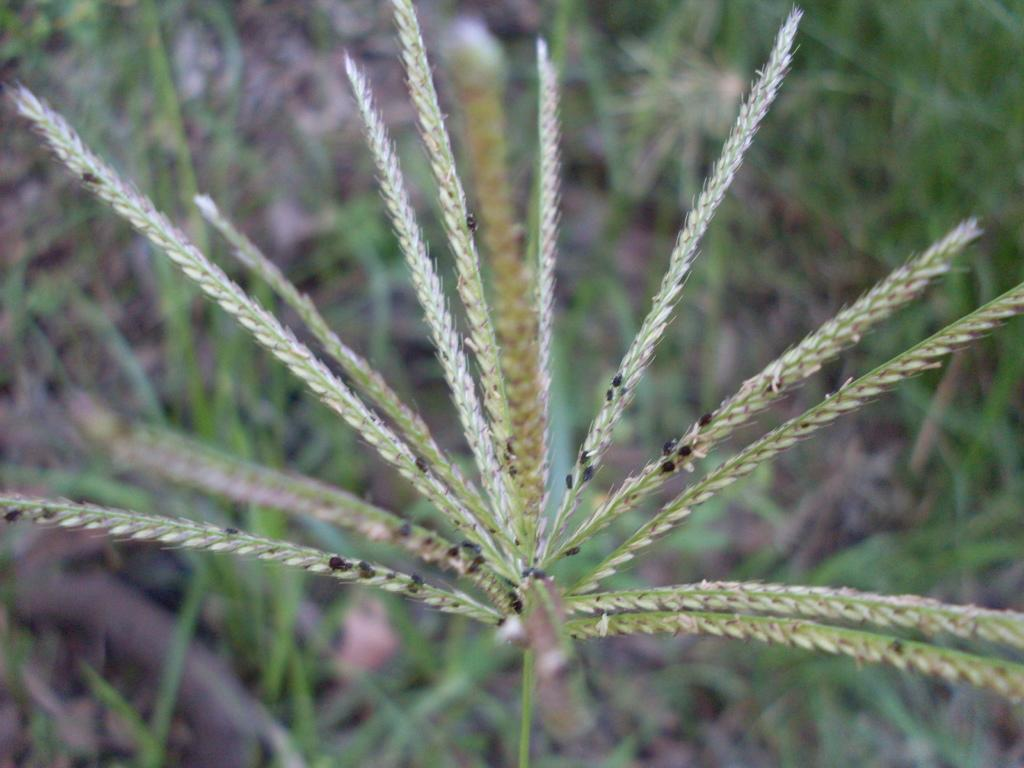What type of living organisms can be seen in the image? Plants can be seen in the image. Are there any other creatures present on the plants? Yes, there are insects on the plants in the image. What is the profit margin of the baseball game being played in the image? There is no baseball game present in the image, so it is not possible to determine the profit margin. 